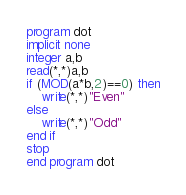Convert code to text. <code><loc_0><loc_0><loc_500><loc_500><_FORTRAN_>program dot
implicit none
integer a,b
read(*,*)a,b
if (MOD(a*b,2)==0) then
    write(*,*)"Even"
else
    write(*,*)"Odd"
end if
stop
end program dot


</code> 